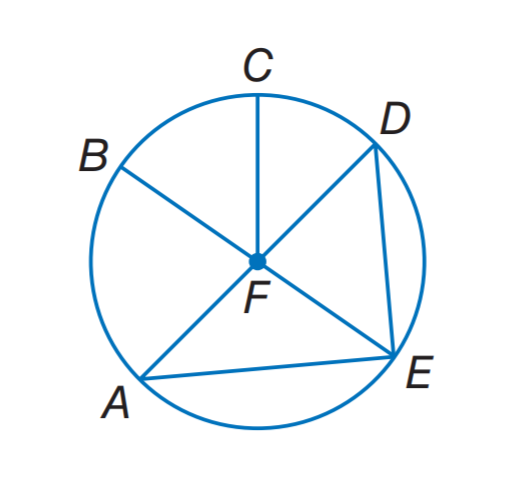Answer the mathemtical geometry problem and directly provide the correct option letter.
Question: In \odot F, if D A = 7.4, what is E F?
Choices: A: 3.7 B: 7.4 C: 11.1 D: 14.8 A 